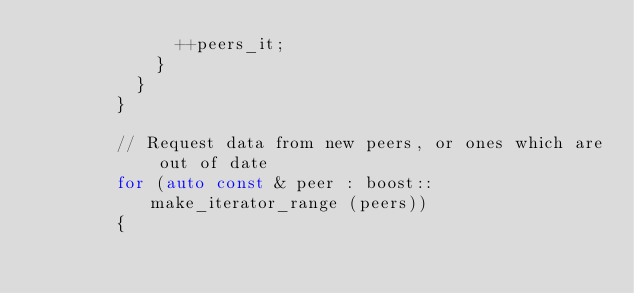Convert code to text. <code><loc_0><loc_0><loc_500><loc_500><_C++_>							++peers_it;
						}
					}
				}

				// Request data from new peers, or ones which are out of date
				for (auto const & peer : boost::make_iterator_range (peers))
				{</code> 